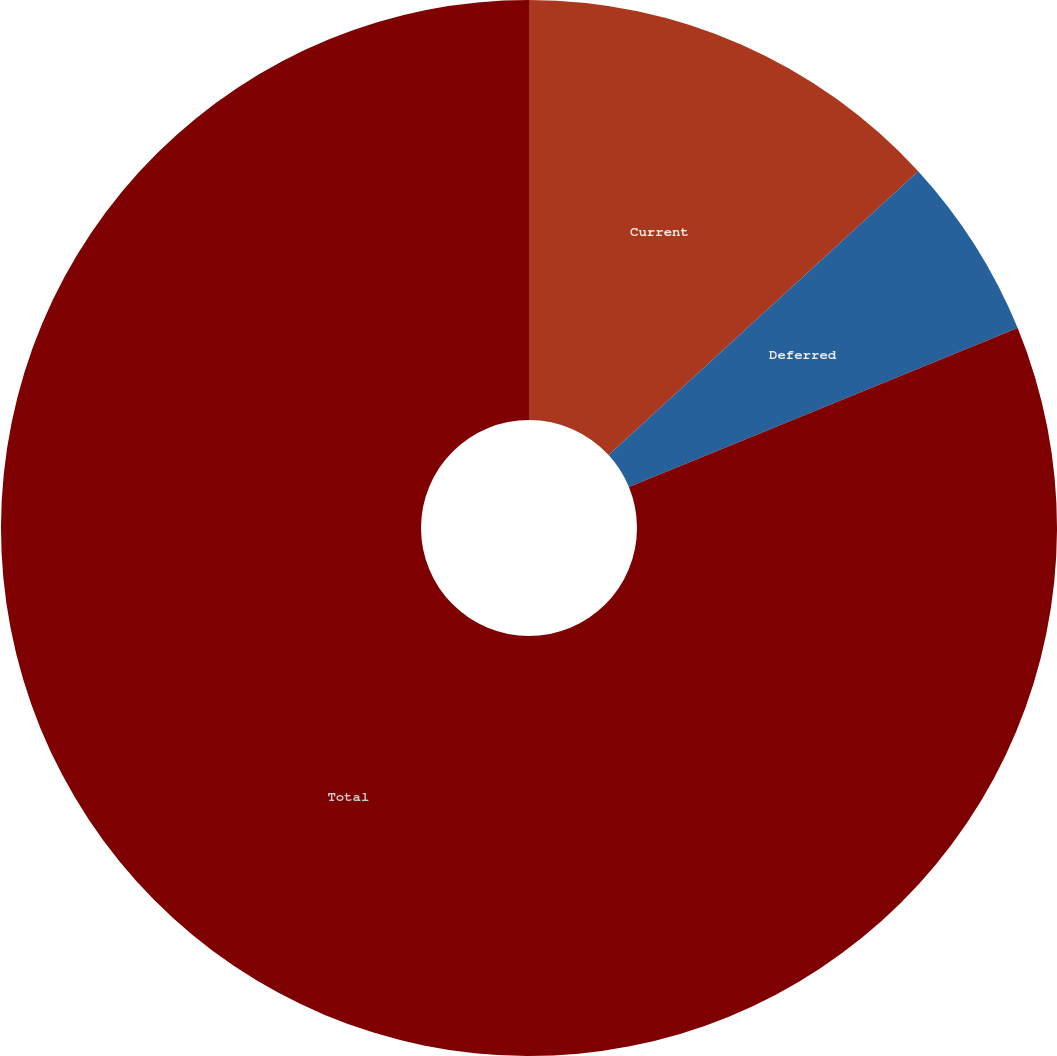Convert chart to OTSL. <chart><loc_0><loc_0><loc_500><loc_500><pie_chart><fcel>Current<fcel>Deferred<fcel>Total<nl><fcel>13.19%<fcel>5.63%<fcel>81.18%<nl></chart> 